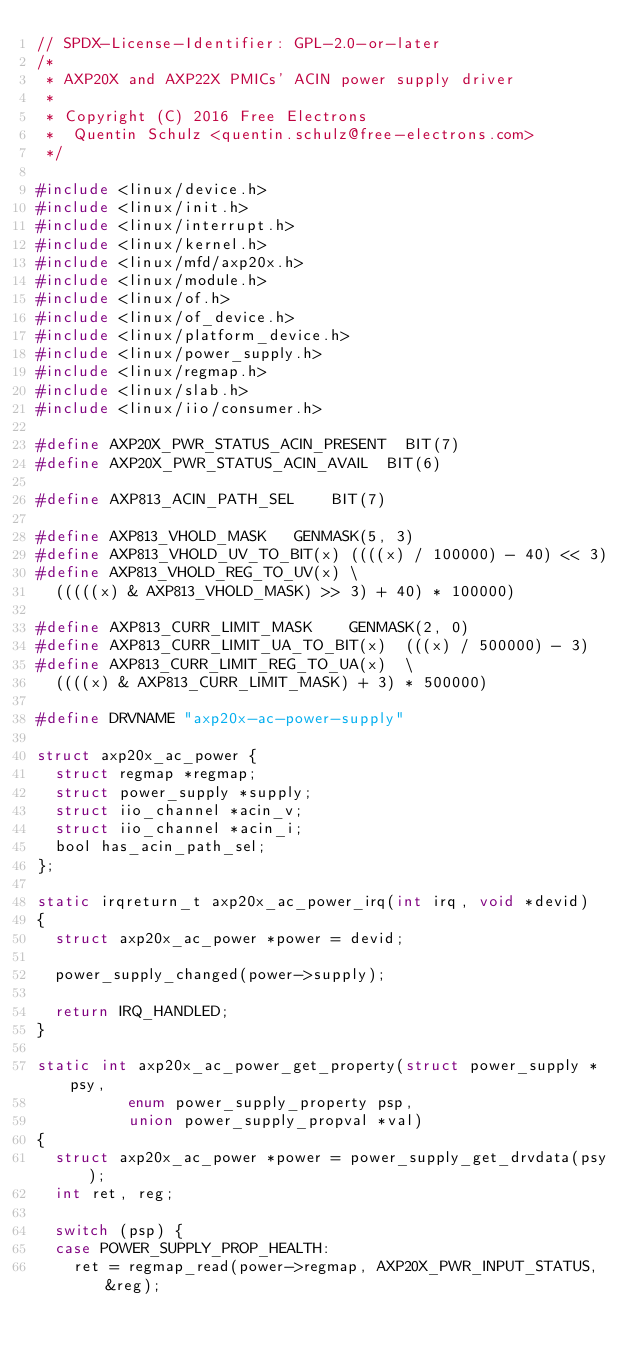Convert code to text. <code><loc_0><loc_0><loc_500><loc_500><_C_>// SPDX-License-Identifier: GPL-2.0-or-later
/*
 * AXP20X and AXP22X PMICs' ACIN power supply driver
 *
 * Copyright (C) 2016 Free Electrons
 *	Quentin Schulz <quentin.schulz@free-electrons.com>
 */

#include <linux/device.h>
#include <linux/init.h>
#include <linux/interrupt.h>
#include <linux/kernel.h>
#include <linux/mfd/axp20x.h>
#include <linux/module.h>
#include <linux/of.h>
#include <linux/of_device.h>
#include <linux/platform_device.h>
#include <linux/power_supply.h>
#include <linux/regmap.h>
#include <linux/slab.h>
#include <linux/iio/consumer.h>

#define AXP20X_PWR_STATUS_ACIN_PRESENT	BIT(7)
#define AXP20X_PWR_STATUS_ACIN_AVAIL	BIT(6)

#define AXP813_ACIN_PATH_SEL		BIT(7)

#define AXP813_VHOLD_MASK		GENMASK(5, 3)
#define AXP813_VHOLD_UV_TO_BIT(x)	((((x) / 100000) - 40) << 3)
#define AXP813_VHOLD_REG_TO_UV(x)	\
	(((((x) & AXP813_VHOLD_MASK) >> 3) + 40) * 100000)

#define AXP813_CURR_LIMIT_MASK		GENMASK(2, 0)
#define AXP813_CURR_LIMIT_UA_TO_BIT(x)	(((x) / 500000) - 3)
#define AXP813_CURR_LIMIT_REG_TO_UA(x)	\
	((((x) & AXP813_CURR_LIMIT_MASK) + 3) * 500000)

#define DRVNAME "axp20x-ac-power-supply"

struct axp20x_ac_power {
	struct regmap *regmap;
	struct power_supply *supply;
	struct iio_channel *acin_v;
	struct iio_channel *acin_i;
	bool has_acin_path_sel;
};

static irqreturn_t axp20x_ac_power_irq(int irq, void *devid)
{
	struct axp20x_ac_power *power = devid;

	power_supply_changed(power->supply);

	return IRQ_HANDLED;
}

static int axp20x_ac_power_get_property(struct power_supply *psy,
					enum power_supply_property psp,
					union power_supply_propval *val)
{
	struct axp20x_ac_power *power = power_supply_get_drvdata(psy);
	int ret, reg;

	switch (psp) {
	case POWER_SUPPLY_PROP_HEALTH:
		ret = regmap_read(power->regmap, AXP20X_PWR_INPUT_STATUS, &reg);</code> 